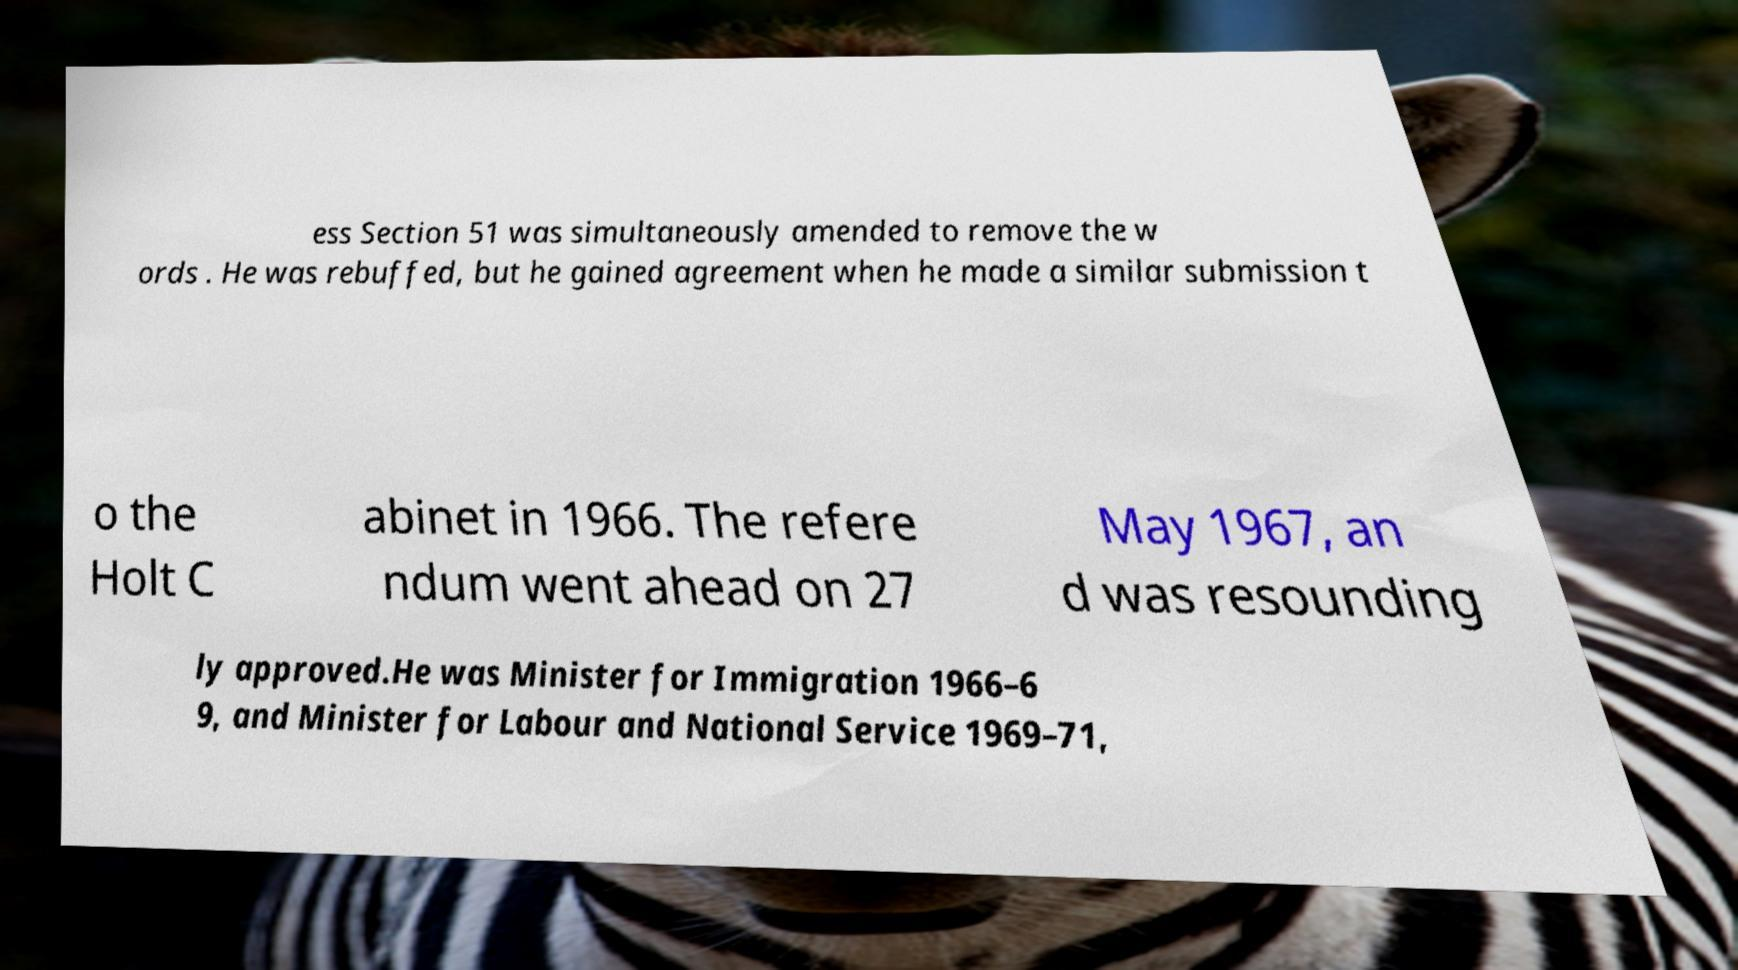There's text embedded in this image that I need extracted. Can you transcribe it verbatim? ess Section 51 was simultaneously amended to remove the w ords . He was rebuffed, but he gained agreement when he made a similar submission t o the Holt C abinet in 1966. The refere ndum went ahead on 27 May 1967, an d was resounding ly approved.He was Minister for Immigration 1966–6 9, and Minister for Labour and National Service 1969–71, 